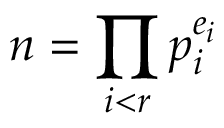Convert formula to latex. <formula><loc_0><loc_0><loc_500><loc_500>n = \prod _ { i < r } p _ { i } ^ { e _ { i } }</formula> 